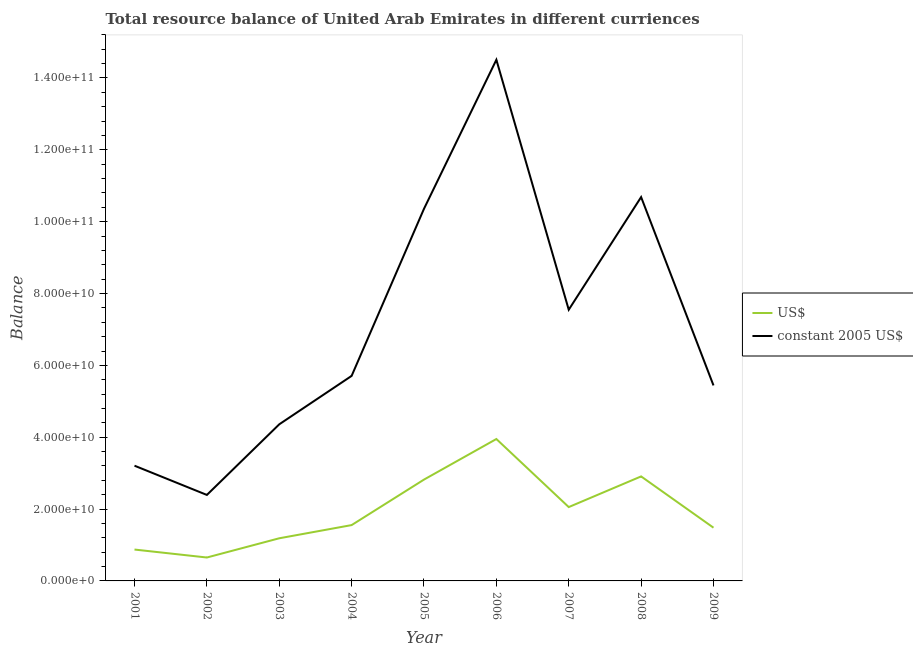How many different coloured lines are there?
Your response must be concise. 2. What is the resource balance in us$ in 2008?
Your answer should be compact. 2.91e+1. Across all years, what is the maximum resource balance in us$?
Your response must be concise. 3.95e+1. Across all years, what is the minimum resource balance in us$?
Provide a succinct answer. 6.52e+09. What is the total resource balance in us$ in the graph?
Your answer should be compact. 1.75e+11. What is the difference between the resource balance in constant us$ in 2003 and that in 2007?
Give a very brief answer. -3.19e+1. What is the difference between the resource balance in us$ in 2004 and the resource balance in constant us$ in 2007?
Ensure brevity in your answer.  -6.00e+1. What is the average resource balance in us$ per year?
Offer a terse response. 1.94e+1. In the year 2003, what is the difference between the resource balance in constant us$ and resource balance in us$?
Your response must be concise. 3.17e+1. In how many years, is the resource balance in constant us$ greater than 136000000000 units?
Keep it short and to the point. 1. What is the ratio of the resource balance in us$ in 2001 to that in 2007?
Offer a very short reply. 0.42. Is the difference between the resource balance in constant us$ in 2004 and 2006 greater than the difference between the resource balance in us$ in 2004 and 2006?
Offer a terse response. No. What is the difference between the highest and the second highest resource balance in us$?
Your response must be concise. 1.04e+1. What is the difference between the highest and the lowest resource balance in us$?
Provide a succinct answer. 3.30e+1. Does the resource balance in constant us$ monotonically increase over the years?
Provide a succinct answer. No. Is the resource balance in constant us$ strictly less than the resource balance in us$ over the years?
Ensure brevity in your answer.  No. What is the difference between two consecutive major ticks on the Y-axis?
Provide a short and direct response. 2.00e+1. Are the values on the major ticks of Y-axis written in scientific E-notation?
Make the answer very short. Yes. Does the graph contain grids?
Offer a terse response. No. Where does the legend appear in the graph?
Your answer should be compact. Center right. How are the legend labels stacked?
Give a very brief answer. Vertical. What is the title of the graph?
Make the answer very short. Total resource balance of United Arab Emirates in different curriences. Does "External balance on goods" appear as one of the legend labels in the graph?
Offer a terse response. No. What is the label or title of the Y-axis?
Offer a very short reply. Balance. What is the Balance of US$ in 2001?
Give a very brief answer. 8.73e+09. What is the Balance of constant 2005 US$ in 2001?
Ensure brevity in your answer.  3.21e+1. What is the Balance in US$ in 2002?
Offer a very short reply. 6.52e+09. What is the Balance of constant 2005 US$ in 2002?
Provide a short and direct response. 2.39e+1. What is the Balance in US$ in 2003?
Give a very brief answer. 1.19e+1. What is the Balance of constant 2005 US$ in 2003?
Your answer should be compact. 4.36e+1. What is the Balance of US$ in 2004?
Your answer should be compact. 1.55e+1. What is the Balance in constant 2005 US$ in 2004?
Offer a terse response. 5.71e+1. What is the Balance of US$ in 2005?
Provide a short and direct response. 2.82e+1. What is the Balance in constant 2005 US$ in 2005?
Offer a terse response. 1.04e+11. What is the Balance in US$ in 2006?
Your answer should be compact. 3.95e+1. What is the Balance of constant 2005 US$ in 2006?
Make the answer very short. 1.45e+11. What is the Balance in US$ in 2007?
Your answer should be compact. 2.06e+1. What is the Balance of constant 2005 US$ in 2007?
Make the answer very short. 7.55e+1. What is the Balance of US$ in 2008?
Your response must be concise. 2.91e+1. What is the Balance in constant 2005 US$ in 2008?
Provide a short and direct response. 1.07e+11. What is the Balance of US$ in 2009?
Make the answer very short. 1.48e+1. What is the Balance of constant 2005 US$ in 2009?
Provide a succinct answer. 5.44e+1. Across all years, what is the maximum Balance of US$?
Provide a succinct answer. 3.95e+1. Across all years, what is the maximum Balance of constant 2005 US$?
Ensure brevity in your answer.  1.45e+11. Across all years, what is the minimum Balance of US$?
Your response must be concise. 6.52e+09. Across all years, what is the minimum Balance of constant 2005 US$?
Your response must be concise. 2.39e+1. What is the total Balance in US$ in the graph?
Your answer should be compact. 1.75e+11. What is the total Balance in constant 2005 US$ in the graph?
Ensure brevity in your answer.  6.42e+11. What is the difference between the Balance of US$ in 2001 and that in 2002?
Ensure brevity in your answer.  2.22e+09. What is the difference between the Balance in constant 2005 US$ in 2001 and that in 2002?
Provide a succinct answer. 8.14e+09. What is the difference between the Balance in US$ in 2001 and that in 2003?
Offer a terse response. -3.14e+09. What is the difference between the Balance of constant 2005 US$ in 2001 and that in 2003?
Ensure brevity in your answer.  -1.15e+1. What is the difference between the Balance in US$ in 2001 and that in 2004?
Ensure brevity in your answer.  -6.81e+09. What is the difference between the Balance of constant 2005 US$ in 2001 and that in 2004?
Your answer should be very brief. -2.50e+1. What is the difference between the Balance in US$ in 2001 and that in 2005?
Your response must be concise. -1.95e+1. What is the difference between the Balance in constant 2005 US$ in 2001 and that in 2005?
Offer a very short reply. -7.15e+1. What is the difference between the Balance of US$ in 2001 and that in 2006?
Keep it short and to the point. -3.08e+1. What is the difference between the Balance in constant 2005 US$ in 2001 and that in 2006?
Provide a short and direct response. -1.13e+11. What is the difference between the Balance of US$ in 2001 and that in 2007?
Make the answer very short. -1.18e+1. What is the difference between the Balance in constant 2005 US$ in 2001 and that in 2007?
Make the answer very short. -4.34e+1. What is the difference between the Balance of US$ in 2001 and that in 2008?
Your answer should be very brief. -2.04e+1. What is the difference between the Balance in constant 2005 US$ in 2001 and that in 2008?
Ensure brevity in your answer.  -7.48e+1. What is the difference between the Balance in US$ in 2001 and that in 2009?
Offer a very short reply. -6.09e+09. What is the difference between the Balance in constant 2005 US$ in 2001 and that in 2009?
Give a very brief answer. -2.23e+1. What is the difference between the Balance of US$ in 2002 and that in 2003?
Provide a short and direct response. -5.35e+09. What is the difference between the Balance of constant 2005 US$ in 2002 and that in 2003?
Give a very brief answer. -1.97e+1. What is the difference between the Balance in US$ in 2002 and that in 2004?
Ensure brevity in your answer.  -9.02e+09. What is the difference between the Balance of constant 2005 US$ in 2002 and that in 2004?
Make the answer very short. -3.31e+1. What is the difference between the Balance in US$ in 2002 and that in 2005?
Ensure brevity in your answer.  -2.17e+1. What is the difference between the Balance in constant 2005 US$ in 2002 and that in 2005?
Give a very brief answer. -7.97e+1. What is the difference between the Balance of US$ in 2002 and that in 2006?
Your response must be concise. -3.30e+1. What is the difference between the Balance of constant 2005 US$ in 2002 and that in 2006?
Keep it short and to the point. -1.21e+11. What is the difference between the Balance in US$ in 2002 and that in 2007?
Your answer should be very brief. -1.40e+1. What is the difference between the Balance of constant 2005 US$ in 2002 and that in 2007?
Ensure brevity in your answer.  -5.16e+1. What is the difference between the Balance in US$ in 2002 and that in 2008?
Your answer should be very brief. -2.26e+1. What is the difference between the Balance of constant 2005 US$ in 2002 and that in 2008?
Your answer should be very brief. -8.29e+1. What is the difference between the Balance of US$ in 2002 and that in 2009?
Give a very brief answer. -8.30e+09. What is the difference between the Balance in constant 2005 US$ in 2002 and that in 2009?
Offer a very short reply. -3.05e+1. What is the difference between the Balance in US$ in 2003 and that in 2004?
Your answer should be compact. -3.67e+09. What is the difference between the Balance in constant 2005 US$ in 2003 and that in 2004?
Give a very brief answer. -1.35e+1. What is the difference between the Balance in US$ in 2003 and that in 2005?
Keep it short and to the point. -1.63e+1. What is the difference between the Balance of constant 2005 US$ in 2003 and that in 2005?
Your response must be concise. -6.00e+1. What is the difference between the Balance in US$ in 2003 and that in 2006?
Your answer should be very brief. -2.76e+1. What is the difference between the Balance in constant 2005 US$ in 2003 and that in 2006?
Make the answer very short. -1.01e+11. What is the difference between the Balance of US$ in 2003 and that in 2007?
Give a very brief answer. -8.69e+09. What is the difference between the Balance in constant 2005 US$ in 2003 and that in 2007?
Give a very brief answer. -3.19e+1. What is the difference between the Balance of US$ in 2003 and that in 2008?
Offer a terse response. -1.72e+1. What is the difference between the Balance of constant 2005 US$ in 2003 and that in 2008?
Your response must be concise. -6.33e+1. What is the difference between the Balance of US$ in 2003 and that in 2009?
Your answer should be compact. -2.95e+09. What is the difference between the Balance of constant 2005 US$ in 2003 and that in 2009?
Your answer should be very brief. -1.08e+1. What is the difference between the Balance of US$ in 2004 and that in 2005?
Ensure brevity in your answer.  -1.27e+1. What is the difference between the Balance in constant 2005 US$ in 2004 and that in 2005?
Make the answer very short. -4.65e+1. What is the difference between the Balance of US$ in 2004 and that in 2006?
Give a very brief answer. -2.40e+1. What is the difference between the Balance of constant 2005 US$ in 2004 and that in 2006?
Provide a succinct answer. -8.80e+1. What is the difference between the Balance of US$ in 2004 and that in 2007?
Offer a very short reply. -5.02e+09. What is the difference between the Balance in constant 2005 US$ in 2004 and that in 2007?
Make the answer very short. -1.84e+1. What is the difference between the Balance in US$ in 2004 and that in 2008?
Your response must be concise. -1.36e+1. What is the difference between the Balance in constant 2005 US$ in 2004 and that in 2008?
Keep it short and to the point. -4.98e+1. What is the difference between the Balance in US$ in 2004 and that in 2009?
Offer a very short reply. 7.22e+08. What is the difference between the Balance in constant 2005 US$ in 2004 and that in 2009?
Provide a succinct answer. 2.65e+09. What is the difference between the Balance of US$ in 2005 and that in 2006?
Your answer should be very brief. -1.13e+1. What is the difference between the Balance of constant 2005 US$ in 2005 and that in 2006?
Make the answer very short. -4.15e+1. What is the difference between the Balance in US$ in 2005 and that in 2007?
Provide a succinct answer. 7.65e+09. What is the difference between the Balance in constant 2005 US$ in 2005 and that in 2007?
Ensure brevity in your answer.  2.81e+1. What is the difference between the Balance in US$ in 2005 and that in 2008?
Keep it short and to the point. -8.86e+08. What is the difference between the Balance in constant 2005 US$ in 2005 and that in 2008?
Offer a very short reply. -3.25e+09. What is the difference between the Balance of US$ in 2005 and that in 2009?
Give a very brief answer. 1.34e+1. What is the difference between the Balance of constant 2005 US$ in 2005 and that in 2009?
Provide a short and direct response. 4.92e+1. What is the difference between the Balance of US$ in 2006 and that in 2007?
Your response must be concise. 1.89e+1. What is the difference between the Balance in constant 2005 US$ in 2006 and that in 2007?
Make the answer very short. 6.96e+1. What is the difference between the Balance of US$ in 2006 and that in 2008?
Your answer should be compact. 1.04e+1. What is the difference between the Balance of constant 2005 US$ in 2006 and that in 2008?
Offer a terse response. 3.82e+1. What is the difference between the Balance in US$ in 2006 and that in 2009?
Provide a succinct answer. 2.47e+1. What is the difference between the Balance of constant 2005 US$ in 2006 and that in 2009?
Offer a very short reply. 9.07e+1. What is the difference between the Balance in US$ in 2007 and that in 2008?
Provide a succinct answer. -8.54e+09. What is the difference between the Balance in constant 2005 US$ in 2007 and that in 2008?
Offer a terse response. -3.14e+1. What is the difference between the Balance of US$ in 2007 and that in 2009?
Your response must be concise. 5.74e+09. What is the difference between the Balance in constant 2005 US$ in 2007 and that in 2009?
Ensure brevity in your answer.  2.11e+1. What is the difference between the Balance in US$ in 2008 and that in 2009?
Ensure brevity in your answer.  1.43e+1. What is the difference between the Balance of constant 2005 US$ in 2008 and that in 2009?
Your response must be concise. 5.24e+1. What is the difference between the Balance of US$ in 2001 and the Balance of constant 2005 US$ in 2002?
Offer a very short reply. -1.52e+1. What is the difference between the Balance of US$ in 2001 and the Balance of constant 2005 US$ in 2003?
Offer a terse response. -3.49e+1. What is the difference between the Balance in US$ in 2001 and the Balance in constant 2005 US$ in 2004?
Give a very brief answer. -4.83e+1. What is the difference between the Balance in US$ in 2001 and the Balance in constant 2005 US$ in 2005?
Ensure brevity in your answer.  -9.49e+1. What is the difference between the Balance of US$ in 2001 and the Balance of constant 2005 US$ in 2006?
Your answer should be compact. -1.36e+11. What is the difference between the Balance in US$ in 2001 and the Balance in constant 2005 US$ in 2007?
Your answer should be compact. -6.68e+1. What is the difference between the Balance of US$ in 2001 and the Balance of constant 2005 US$ in 2008?
Offer a terse response. -9.81e+1. What is the difference between the Balance of US$ in 2001 and the Balance of constant 2005 US$ in 2009?
Your response must be concise. -4.57e+1. What is the difference between the Balance of US$ in 2002 and the Balance of constant 2005 US$ in 2003?
Keep it short and to the point. -3.71e+1. What is the difference between the Balance of US$ in 2002 and the Balance of constant 2005 US$ in 2004?
Keep it short and to the point. -5.06e+1. What is the difference between the Balance in US$ in 2002 and the Balance in constant 2005 US$ in 2005?
Offer a terse response. -9.71e+1. What is the difference between the Balance in US$ in 2002 and the Balance in constant 2005 US$ in 2006?
Your response must be concise. -1.39e+11. What is the difference between the Balance of US$ in 2002 and the Balance of constant 2005 US$ in 2007?
Give a very brief answer. -6.90e+1. What is the difference between the Balance in US$ in 2002 and the Balance in constant 2005 US$ in 2008?
Ensure brevity in your answer.  -1.00e+11. What is the difference between the Balance of US$ in 2002 and the Balance of constant 2005 US$ in 2009?
Keep it short and to the point. -4.79e+1. What is the difference between the Balance of US$ in 2003 and the Balance of constant 2005 US$ in 2004?
Keep it short and to the point. -4.52e+1. What is the difference between the Balance in US$ in 2003 and the Balance in constant 2005 US$ in 2005?
Your answer should be very brief. -9.17e+1. What is the difference between the Balance in US$ in 2003 and the Balance in constant 2005 US$ in 2006?
Give a very brief answer. -1.33e+11. What is the difference between the Balance of US$ in 2003 and the Balance of constant 2005 US$ in 2007?
Provide a short and direct response. -6.36e+1. What is the difference between the Balance in US$ in 2003 and the Balance in constant 2005 US$ in 2008?
Keep it short and to the point. -9.50e+1. What is the difference between the Balance of US$ in 2003 and the Balance of constant 2005 US$ in 2009?
Your answer should be compact. -4.26e+1. What is the difference between the Balance of US$ in 2004 and the Balance of constant 2005 US$ in 2005?
Offer a terse response. -8.81e+1. What is the difference between the Balance in US$ in 2004 and the Balance in constant 2005 US$ in 2006?
Make the answer very short. -1.30e+11. What is the difference between the Balance in US$ in 2004 and the Balance in constant 2005 US$ in 2007?
Offer a terse response. -6.00e+1. What is the difference between the Balance in US$ in 2004 and the Balance in constant 2005 US$ in 2008?
Ensure brevity in your answer.  -9.13e+1. What is the difference between the Balance in US$ in 2004 and the Balance in constant 2005 US$ in 2009?
Provide a short and direct response. -3.89e+1. What is the difference between the Balance of US$ in 2005 and the Balance of constant 2005 US$ in 2006?
Make the answer very short. -1.17e+11. What is the difference between the Balance of US$ in 2005 and the Balance of constant 2005 US$ in 2007?
Your answer should be very brief. -4.73e+1. What is the difference between the Balance of US$ in 2005 and the Balance of constant 2005 US$ in 2008?
Give a very brief answer. -7.86e+1. What is the difference between the Balance of US$ in 2005 and the Balance of constant 2005 US$ in 2009?
Your answer should be compact. -2.62e+1. What is the difference between the Balance of US$ in 2006 and the Balance of constant 2005 US$ in 2007?
Provide a succinct answer. -3.60e+1. What is the difference between the Balance in US$ in 2006 and the Balance in constant 2005 US$ in 2008?
Ensure brevity in your answer.  -6.73e+1. What is the difference between the Balance in US$ in 2006 and the Balance in constant 2005 US$ in 2009?
Your answer should be compact. -1.49e+1. What is the difference between the Balance of US$ in 2007 and the Balance of constant 2005 US$ in 2008?
Make the answer very short. -8.63e+1. What is the difference between the Balance of US$ in 2007 and the Balance of constant 2005 US$ in 2009?
Provide a succinct answer. -3.39e+1. What is the difference between the Balance in US$ in 2008 and the Balance in constant 2005 US$ in 2009?
Your answer should be very brief. -2.53e+1. What is the average Balance in US$ per year?
Offer a terse response. 1.94e+1. What is the average Balance of constant 2005 US$ per year?
Ensure brevity in your answer.  7.13e+1. In the year 2001, what is the difference between the Balance of US$ and Balance of constant 2005 US$?
Provide a succinct answer. -2.33e+1. In the year 2002, what is the difference between the Balance of US$ and Balance of constant 2005 US$?
Your response must be concise. -1.74e+1. In the year 2003, what is the difference between the Balance in US$ and Balance in constant 2005 US$?
Give a very brief answer. -3.17e+1. In the year 2004, what is the difference between the Balance in US$ and Balance in constant 2005 US$?
Your response must be concise. -4.15e+1. In the year 2005, what is the difference between the Balance of US$ and Balance of constant 2005 US$?
Offer a terse response. -7.54e+1. In the year 2006, what is the difference between the Balance in US$ and Balance in constant 2005 US$?
Keep it short and to the point. -1.06e+11. In the year 2007, what is the difference between the Balance of US$ and Balance of constant 2005 US$?
Give a very brief answer. -5.49e+1. In the year 2008, what is the difference between the Balance of US$ and Balance of constant 2005 US$?
Your answer should be compact. -7.78e+1. In the year 2009, what is the difference between the Balance in US$ and Balance in constant 2005 US$?
Provide a succinct answer. -3.96e+1. What is the ratio of the Balance in US$ in 2001 to that in 2002?
Ensure brevity in your answer.  1.34. What is the ratio of the Balance of constant 2005 US$ in 2001 to that in 2002?
Offer a very short reply. 1.34. What is the ratio of the Balance of US$ in 2001 to that in 2003?
Offer a very short reply. 0.74. What is the ratio of the Balance of constant 2005 US$ in 2001 to that in 2003?
Provide a succinct answer. 0.74. What is the ratio of the Balance of US$ in 2001 to that in 2004?
Offer a very short reply. 0.56. What is the ratio of the Balance of constant 2005 US$ in 2001 to that in 2004?
Provide a short and direct response. 0.56. What is the ratio of the Balance of US$ in 2001 to that in 2005?
Your answer should be compact. 0.31. What is the ratio of the Balance in constant 2005 US$ in 2001 to that in 2005?
Make the answer very short. 0.31. What is the ratio of the Balance in US$ in 2001 to that in 2006?
Provide a short and direct response. 0.22. What is the ratio of the Balance of constant 2005 US$ in 2001 to that in 2006?
Ensure brevity in your answer.  0.22. What is the ratio of the Balance in US$ in 2001 to that in 2007?
Ensure brevity in your answer.  0.42. What is the ratio of the Balance in constant 2005 US$ in 2001 to that in 2007?
Provide a succinct answer. 0.42. What is the ratio of the Balance of US$ in 2001 to that in 2008?
Offer a very short reply. 0.3. What is the ratio of the Balance of constant 2005 US$ in 2001 to that in 2008?
Offer a terse response. 0.3. What is the ratio of the Balance of US$ in 2001 to that in 2009?
Provide a short and direct response. 0.59. What is the ratio of the Balance in constant 2005 US$ in 2001 to that in 2009?
Your answer should be compact. 0.59. What is the ratio of the Balance of US$ in 2002 to that in 2003?
Keep it short and to the point. 0.55. What is the ratio of the Balance in constant 2005 US$ in 2002 to that in 2003?
Your answer should be compact. 0.55. What is the ratio of the Balance in US$ in 2002 to that in 2004?
Provide a short and direct response. 0.42. What is the ratio of the Balance of constant 2005 US$ in 2002 to that in 2004?
Offer a very short reply. 0.42. What is the ratio of the Balance of US$ in 2002 to that in 2005?
Offer a terse response. 0.23. What is the ratio of the Balance of constant 2005 US$ in 2002 to that in 2005?
Offer a terse response. 0.23. What is the ratio of the Balance of US$ in 2002 to that in 2006?
Your answer should be compact. 0.17. What is the ratio of the Balance of constant 2005 US$ in 2002 to that in 2006?
Your answer should be very brief. 0.17. What is the ratio of the Balance of US$ in 2002 to that in 2007?
Your answer should be compact. 0.32. What is the ratio of the Balance of constant 2005 US$ in 2002 to that in 2007?
Ensure brevity in your answer.  0.32. What is the ratio of the Balance of US$ in 2002 to that in 2008?
Keep it short and to the point. 0.22. What is the ratio of the Balance of constant 2005 US$ in 2002 to that in 2008?
Offer a very short reply. 0.22. What is the ratio of the Balance of US$ in 2002 to that in 2009?
Offer a very short reply. 0.44. What is the ratio of the Balance of constant 2005 US$ in 2002 to that in 2009?
Keep it short and to the point. 0.44. What is the ratio of the Balance of US$ in 2003 to that in 2004?
Your answer should be compact. 0.76. What is the ratio of the Balance of constant 2005 US$ in 2003 to that in 2004?
Offer a terse response. 0.76. What is the ratio of the Balance of US$ in 2003 to that in 2005?
Provide a succinct answer. 0.42. What is the ratio of the Balance in constant 2005 US$ in 2003 to that in 2005?
Make the answer very short. 0.42. What is the ratio of the Balance of US$ in 2003 to that in 2006?
Keep it short and to the point. 0.3. What is the ratio of the Balance in constant 2005 US$ in 2003 to that in 2006?
Offer a terse response. 0.3. What is the ratio of the Balance in US$ in 2003 to that in 2007?
Offer a very short reply. 0.58. What is the ratio of the Balance of constant 2005 US$ in 2003 to that in 2007?
Your answer should be compact. 0.58. What is the ratio of the Balance in US$ in 2003 to that in 2008?
Provide a short and direct response. 0.41. What is the ratio of the Balance of constant 2005 US$ in 2003 to that in 2008?
Your response must be concise. 0.41. What is the ratio of the Balance in US$ in 2003 to that in 2009?
Offer a very short reply. 0.8. What is the ratio of the Balance in constant 2005 US$ in 2003 to that in 2009?
Keep it short and to the point. 0.8. What is the ratio of the Balance of US$ in 2004 to that in 2005?
Offer a terse response. 0.55. What is the ratio of the Balance of constant 2005 US$ in 2004 to that in 2005?
Provide a short and direct response. 0.55. What is the ratio of the Balance in US$ in 2004 to that in 2006?
Ensure brevity in your answer.  0.39. What is the ratio of the Balance of constant 2005 US$ in 2004 to that in 2006?
Make the answer very short. 0.39. What is the ratio of the Balance in US$ in 2004 to that in 2007?
Make the answer very short. 0.76. What is the ratio of the Balance of constant 2005 US$ in 2004 to that in 2007?
Your response must be concise. 0.76. What is the ratio of the Balance of US$ in 2004 to that in 2008?
Offer a terse response. 0.53. What is the ratio of the Balance in constant 2005 US$ in 2004 to that in 2008?
Give a very brief answer. 0.53. What is the ratio of the Balance of US$ in 2004 to that in 2009?
Provide a short and direct response. 1.05. What is the ratio of the Balance in constant 2005 US$ in 2004 to that in 2009?
Offer a terse response. 1.05. What is the ratio of the Balance in US$ in 2005 to that in 2006?
Your answer should be very brief. 0.71. What is the ratio of the Balance of constant 2005 US$ in 2005 to that in 2006?
Provide a succinct answer. 0.71. What is the ratio of the Balance of US$ in 2005 to that in 2007?
Ensure brevity in your answer.  1.37. What is the ratio of the Balance of constant 2005 US$ in 2005 to that in 2007?
Keep it short and to the point. 1.37. What is the ratio of the Balance of US$ in 2005 to that in 2008?
Give a very brief answer. 0.97. What is the ratio of the Balance in constant 2005 US$ in 2005 to that in 2008?
Provide a succinct answer. 0.97. What is the ratio of the Balance of US$ in 2005 to that in 2009?
Your response must be concise. 1.9. What is the ratio of the Balance in constant 2005 US$ in 2005 to that in 2009?
Provide a succinct answer. 1.9. What is the ratio of the Balance of US$ in 2006 to that in 2007?
Ensure brevity in your answer.  1.92. What is the ratio of the Balance of constant 2005 US$ in 2006 to that in 2007?
Provide a succinct answer. 1.92. What is the ratio of the Balance of US$ in 2006 to that in 2008?
Ensure brevity in your answer.  1.36. What is the ratio of the Balance in constant 2005 US$ in 2006 to that in 2008?
Make the answer very short. 1.36. What is the ratio of the Balance of US$ in 2006 to that in 2009?
Keep it short and to the point. 2.67. What is the ratio of the Balance in constant 2005 US$ in 2006 to that in 2009?
Give a very brief answer. 2.67. What is the ratio of the Balance of US$ in 2007 to that in 2008?
Offer a terse response. 0.71. What is the ratio of the Balance of constant 2005 US$ in 2007 to that in 2008?
Ensure brevity in your answer.  0.71. What is the ratio of the Balance of US$ in 2007 to that in 2009?
Make the answer very short. 1.39. What is the ratio of the Balance of constant 2005 US$ in 2007 to that in 2009?
Your answer should be very brief. 1.39. What is the ratio of the Balance in US$ in 2008 to that in 2009?
Give a very brief answer. 1.96. What is the ratio of the Balance in constant 2005 US$ in 2008 to that in 2009?
Give a very brief answer. 1.96. What is the difference between the highest and the second highest Balance in US$?
Offer a terse response. 1.04e+1. What is the difference between the highest and the second highest Balance in constant 2005 US$?
Keep it short and to the point. 3.82e+1. What is the difference between the highest and the lowest Balance in US$?
Provide a succinct answer. 3.30e+1. What is the difference between the highest and the lowest Balance in constant 2005 US$?
Provide a succinct answer. 1.21e+11. 